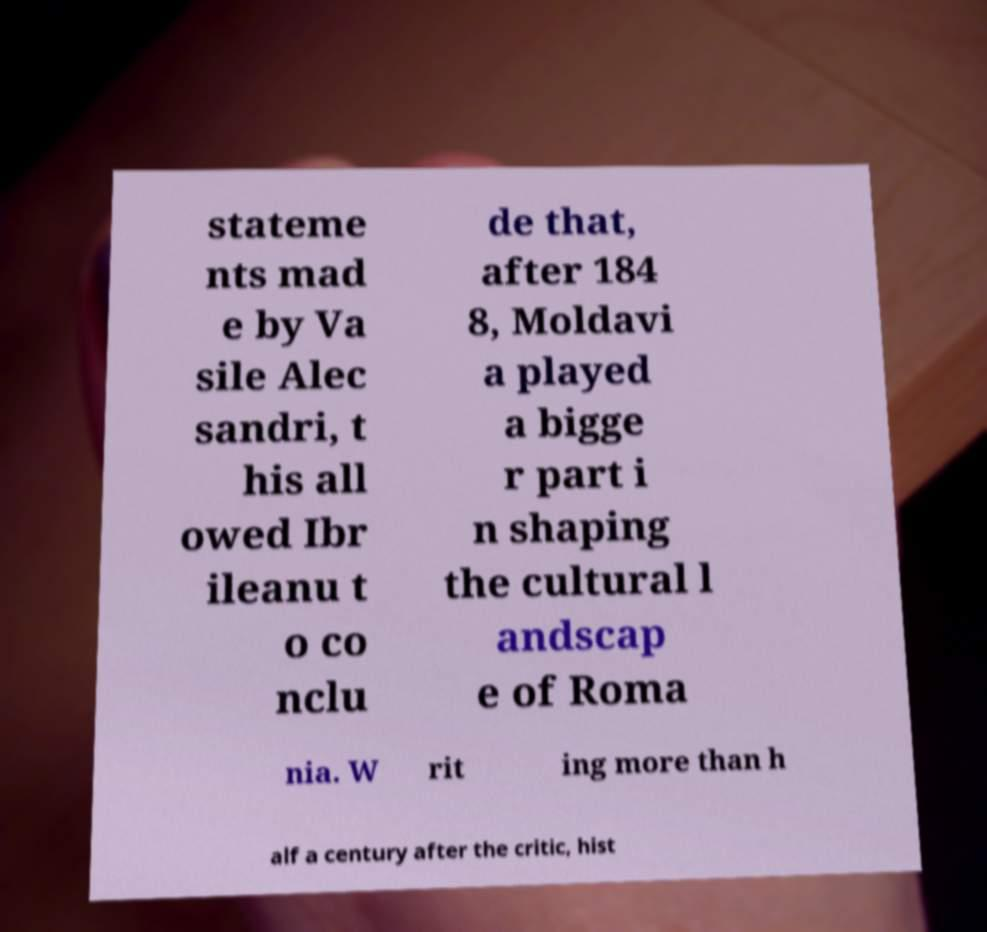Can you read and provide the text displayed in the image?This photo seems to have some interesting text. Can you extract and type it out for me? stateme nts mad e by Va sile Alec sandri, t his all owed Ibr ileanu t o co nclu de that, after 184 8, Moldavi a played a bigge r part i n shaping the cultural l andscap e of Roma nia. W rit ing more than h alf a century after the critic, hist 